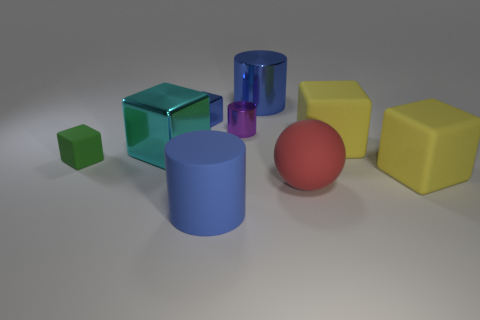Subtract all gray blocks. Subtract all blue cylinders. How many blocks are left? 5 Add 1 big rubber cylinders. How many objects exist? 10 Subtract all cylinders. How many objects are left? 6 Add 2 big blue shiny cylinders. How many big blue shiny cylinders exist? 3 Subtract 0 blue balls. How many objects are left? 9 Subtract all green cubes. Subtract all red balls. How many objects are left? 7 Add 3 tiny green rubber cubes. How many tiny green rubber cubes are left? 4 